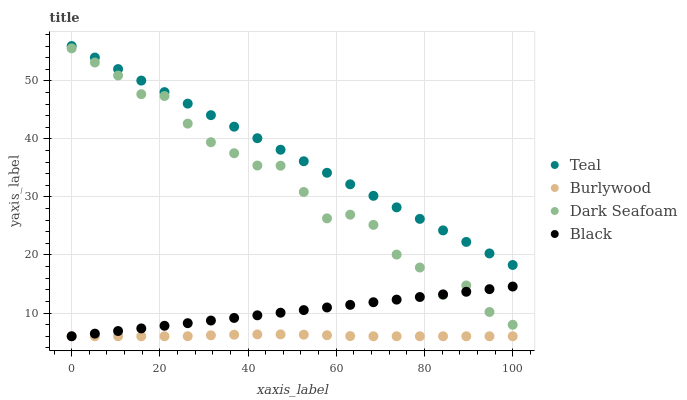Does Burlywood have the minimum area under the curve?
Answer yes or no. Yes. Does Teal have the maximum area under the curve?
Answer yes or no. Yes. Does Dark Seafoam have the minimum area under the curve?
Answer yes or no. No. Does Dark Seafoam have the maximum area under the curve?
Answer yes or no. No. Is Black the smoothest?
Answer yes or no. Yes. Is Dark Seafoam the roughest?
Answer yes or no. Yes. Is Dark Seafoam the smoothest?
Answer yes or no. No. Is Black the roughest?
Answer yes or no. No. Does Burlywood have the lowest value?
Answer yes or no. Yes. Does Dark Seafoam have the lowest value?
Answer yes or no. No. Does Teal have the highest value?
Answer yes or no. Yes. Does Dark Seafoam have the highest value?
Answer yes or no. No. Is Dark Seafoam less than Teal?
Answer yes or no. Yes. Is Teal greater than Burlywood?
Answer yes or no. Yes. Does Black intersect Burlywood?
Answer yes or no. Yes. Is Black less than Burlywood?
Answer yes or no. No. Is Black greater than Burlywood?
Answer yes or no. No. Does Dark Seafoam intersect Teal?
Answer yes or no. No. 